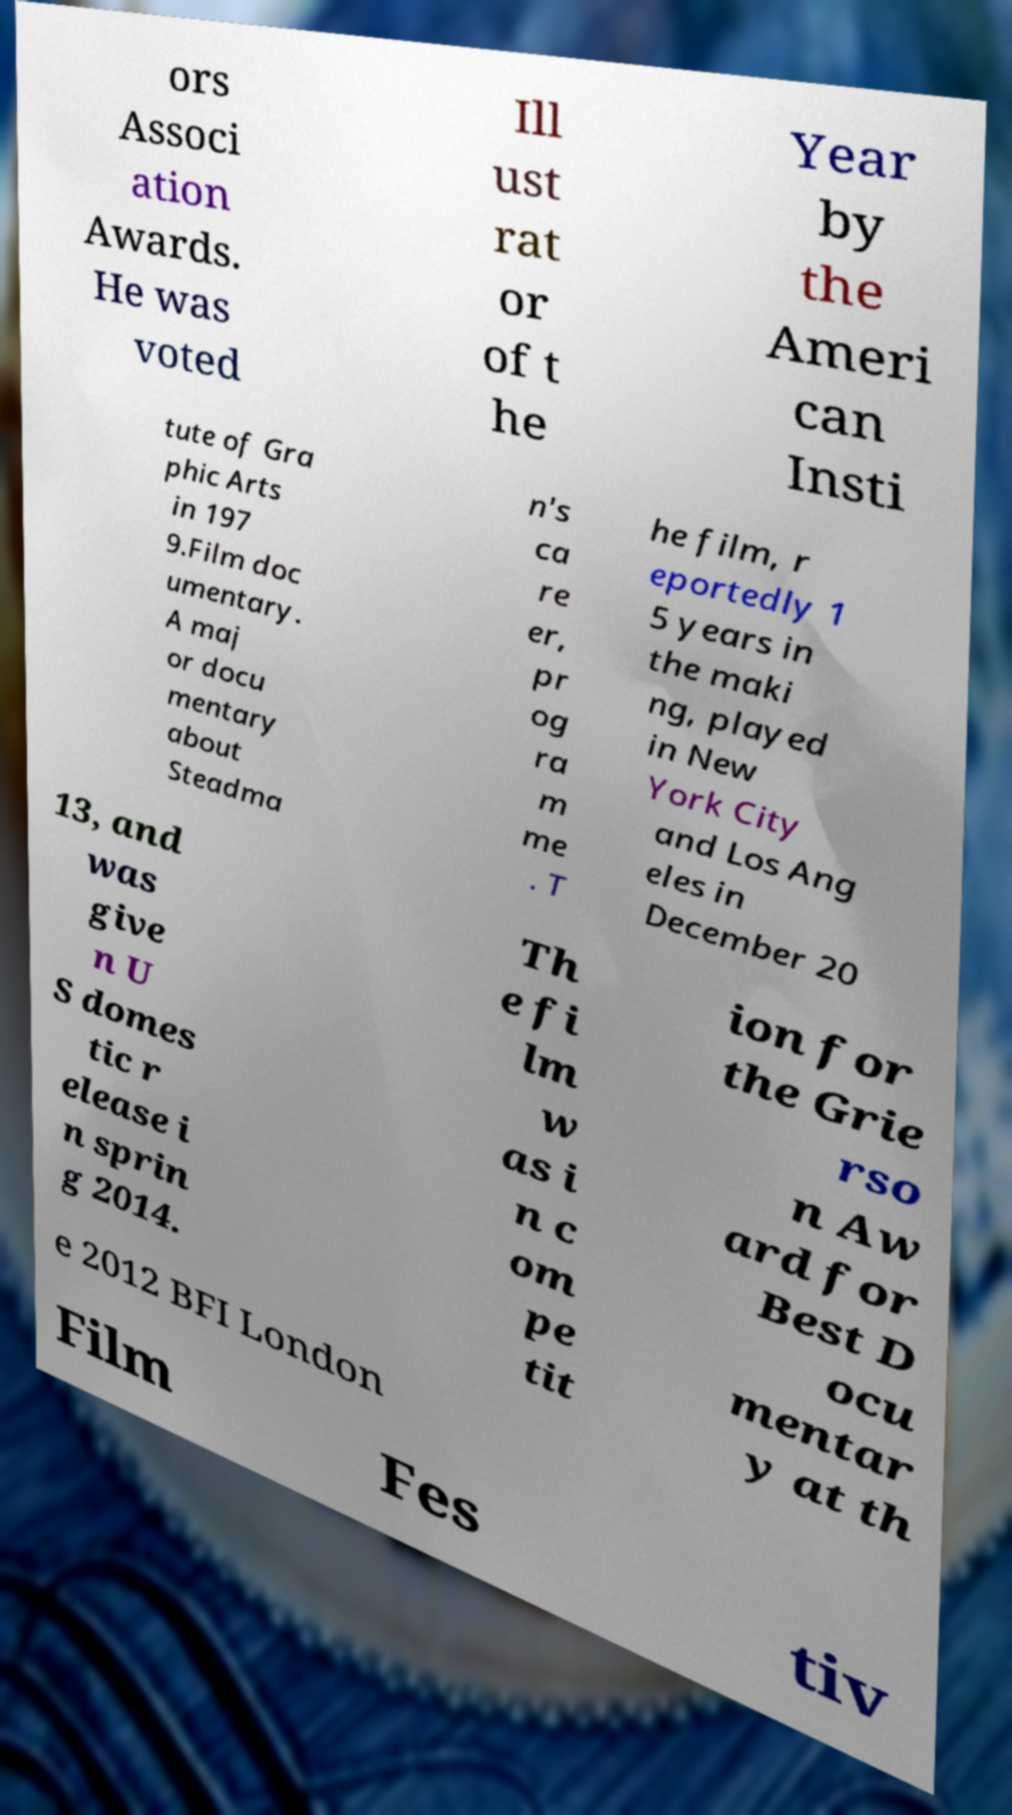For documentation purposes, I need the text within this image transcribed. Could you provide that? ors Associ ation Awards. He was voted Ill ust rat or of t he Year by the Ameri can Insti tute of Gra phic Arts in 197 9.Film doc umentary. A maj or docu mentary about Steadma n's ca re er, pr og ra m me . T he film, r eportedly 1 5 years in the maki ng, played in New York City and Los Ang eles in December 20 13, and was give n U S domes tic r elease i n sprin g 2014. Th e fi lm w as i n c om pe tit ion for the Grie rso n Aw ard for Best D ocu mentar y at th e 2012 BFI London Film Fes tiv 